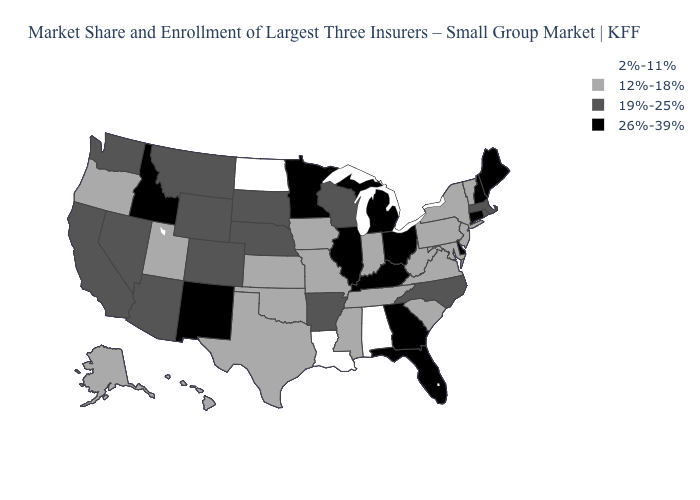What is the value of Utah?
Write a very short answer. 12%-18%. Which states have the highest value in the USA?
Keep it brief. Connecticut, Delaware, Florida, Georgia, Idaho, Illinois, Kentucky, Maine, Michigan, Minnesota, New Hampshire, New Mexico, Ohio. What is the value of Mississippi?
Be succinct. 12%-18%. What is the value of Delaware?
Be succinct. 26%-39%. Name the states that have a value in the range 2%-11%?
Quick response, please. Alabama, Louisiana, North Dakota. Name the states that have a value in the range 12%-18%?
Quick response, please. Alaska, Hawaii, Indiana, Iowa, Kansas, Maryland, Mississippi, Missouri, New Jersey, New York, Oklahoma, Oregon, Pennsylvania, South Carolina, Tennessee, Texas, Utah, Vermont, Virginia, West Virginia. Among the states that border New Jersey , does Delaware have the lowest value?
Concise answer only. No. Which states have the highest value in the USA?
Quick response, please. Connecticut, Delaware, Florida, Georgia, Idaho, Illinois, Kentucky, Maine, Michigan, Minnesota, New Hampshire, New Mexico, Ohio. What is the value of West Virginia?
Short answer required. 12%-18%. Which states have the lowest value in the South?
Write a very short answer. Alabama, Louisiana. What is the value of Idaho?
Short answer required. 26%-39%. Does Indiana have the highest value in the MidWest?
Answer briefly. No. Name the states that have a value in the range 26%-39%?
Quick response, please. Connecticut, Delaware, Florida, Georgia, Idaho, Illinois, Kentucky, Maine, Michigan, Minnesota, New Hampshire, New Mexico, Ohio. Is the legend a continuous bar?
Answer briefly. No. What is the value of Arizona?
Give a very brief answer. 19%-25%. 